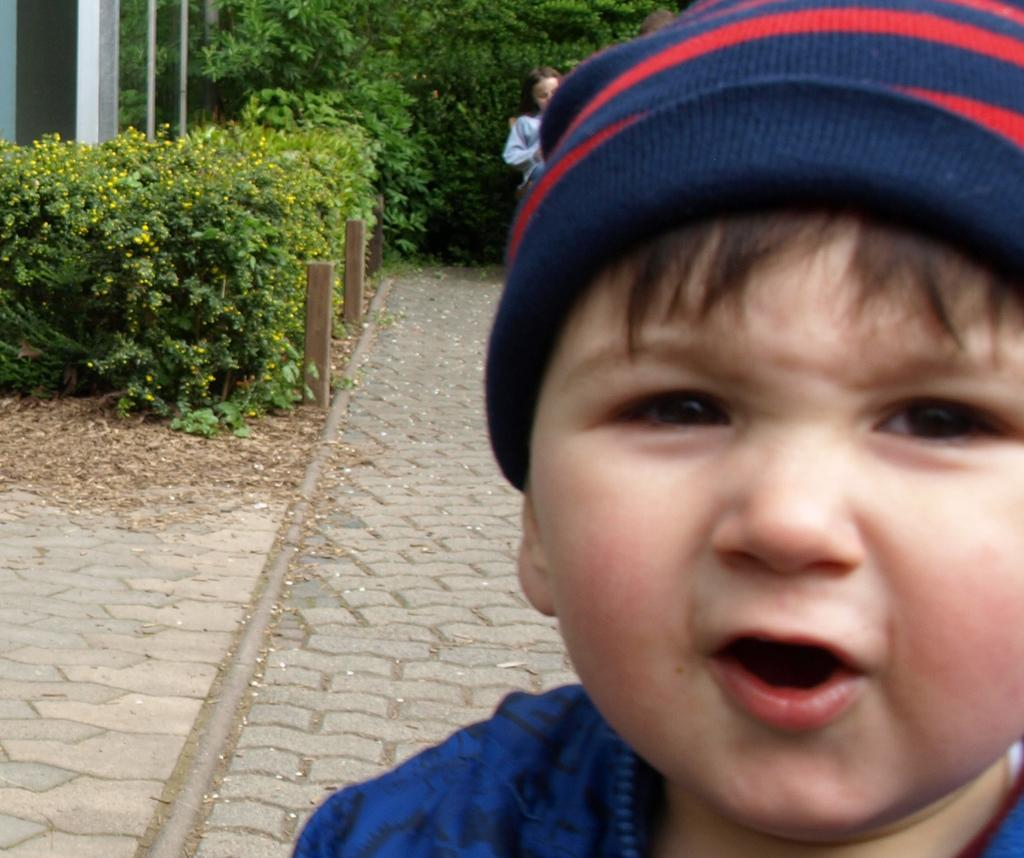What is the gender of the child on the right side of the image? There is a small boy on the right side of the image. Can you describe the position of the girl in relation to the boy? There is a girl behind the boy. What type of vegetation can be seen in the background of the image? There are bamboos and greenery in the background of the image. What type of rhythm can be heard coming from the office in the image? A: There is no office present in the image, and therefore no rhythm can be heard. 